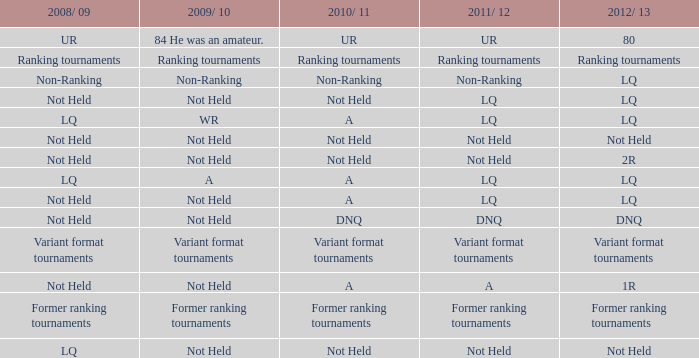When 2011/ 12 is not ranked, what is the 2009/ 10? Non-Ranking. 